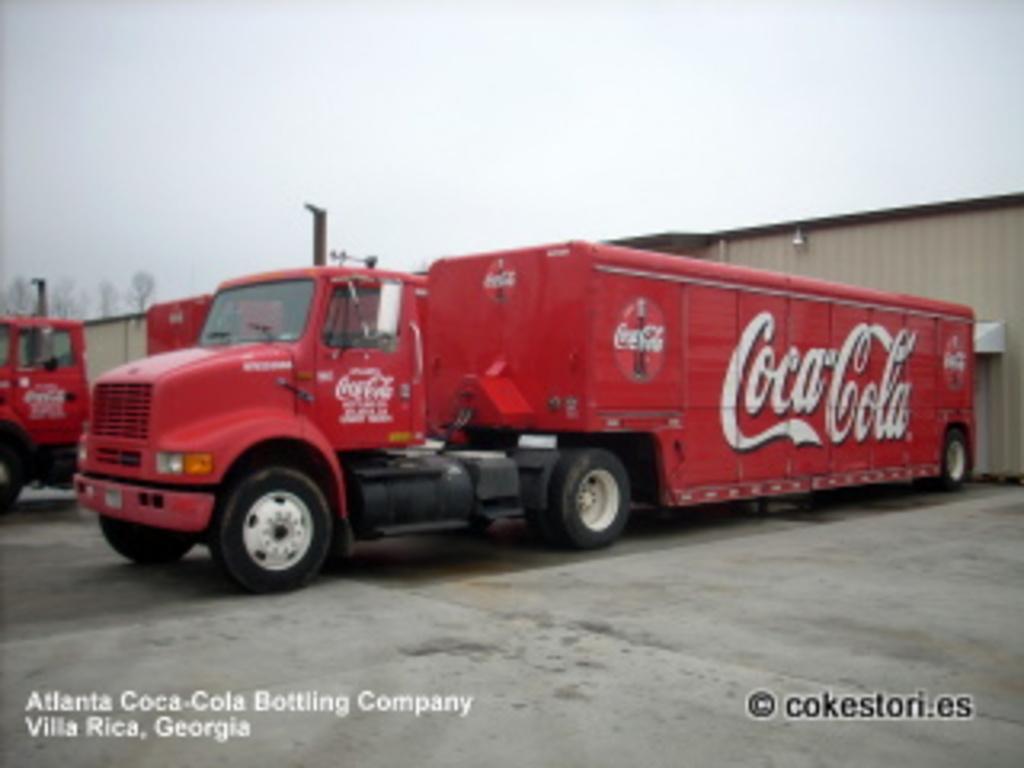Could you give a brief overview of what you see in this image? In this image, we can see trucks in front of the shed. There is a sky at the top of the image. 